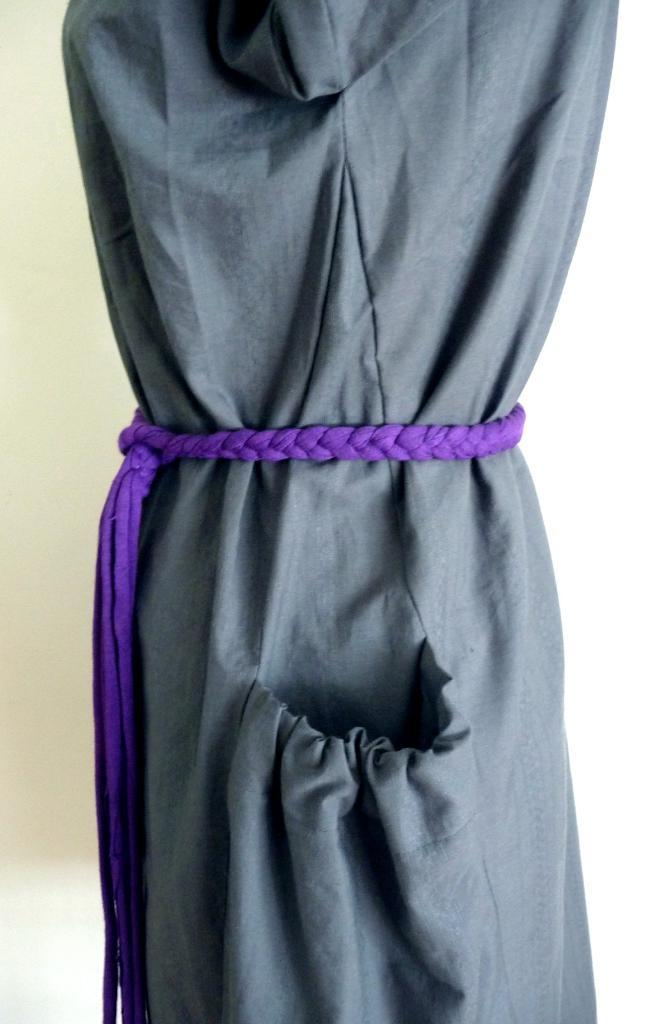What type of clothing is featured in the picture? There is a dress in the picture. What additional features can be seen on the dress? The dress has a belt and a pocket. What can be seen in the background of the picture? There is a white surface in the background of the picture. Is there any eggnog being served on the stage in the image? There is no stage or eggnog present in the image. What type of pest can be seen crawling on the dress in the image? There are no pests visible on the dress in the image. 